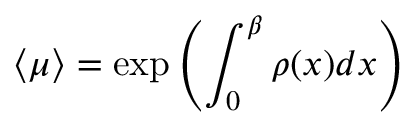Convert formula to latex. <formula><loc_0><loc_0><loc_500><loc_500>\langle \mu \rangle = \exp \left ( \int _ { 0 } ^ { \beta } \rho ( x ) d x \right )</formula> 